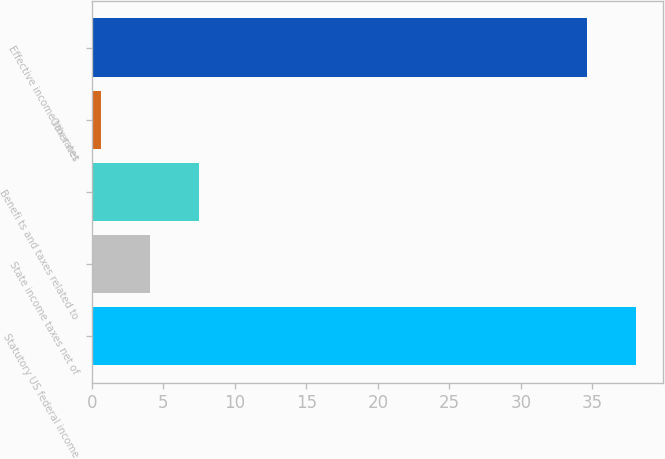<chart> <loc_0><loc_0><loc_500><loc_500><bar_chart><fcel>Statutory US federal income<fcel>State income taxes net of<fcel>Benefi ts and taxes related to<fcel>Other net<fcel>Effective income tax rates<nl><fcel>38.04<fcel>4.04<fcel>7.5<fcel>0.6<fcel>34.6<nl></chart> 